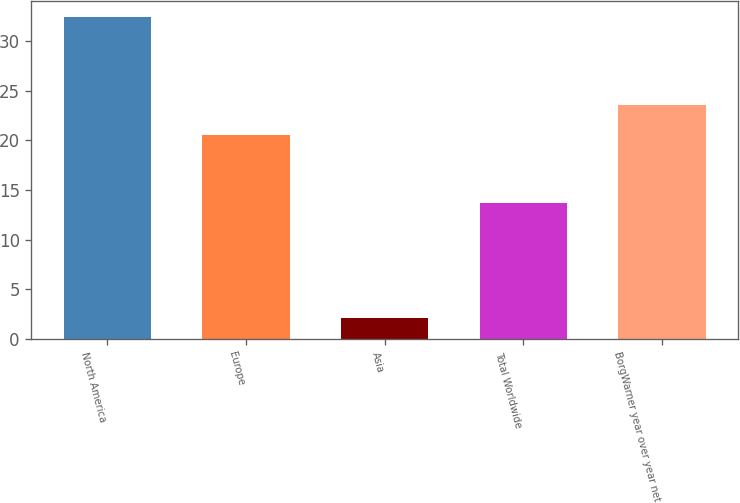<chart> <loc_0><loc_0><loc_500><loc_500><bar_chart><fcel>North America<fcel>Europe<fcel>Asia<fcel>Total Worldwide<fcel>BorgWarner year over year net<nl><fcel>32.4<fcel>20.5<fcel>2.1<fcel>13.7<fcel>23.53<nl></chart> 